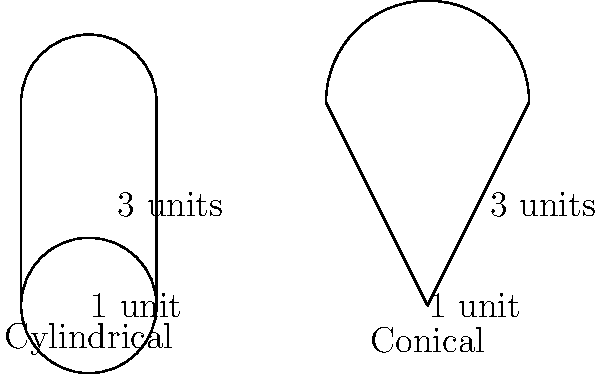You have two protein shaker bottles: a cylindrical one and a conical one. Both are 3 units tall. The cylindrical bottle has a radius of 1 unit, while the conical bottle has a base radius of 1 unit and a top radius of 1.5 units. If you fill the cylindrical bottle completely, what fraction of the conical bottle's volume would be filled with the same amount of protein powder? Let's approach this step-by-step:

1) First, calculate the volume of the cylindrical bottle:
   $$V_{cylinder} = \pi r^2 h = \pi (1)^2 (3) = 3\pi \text{ cubic units}$$

2) Next, calculate the volume of the conical bottle (which is actually a truncated cone):
   $$V_{cone} = \frac{1}{3}\pi h(R^2 + r^2 + Rr)$$
   where $R = 1.5$ (top radius), $r = 1$ (bottom radius), and $h = 3$ (height)
   $$V_{cone} = \frac{1}{3}\pi (3)((1.5)^2 + (1)^2 + 1.5(1)) = \frac{1}{3}\pi (3)(2.25 + 1 + 1.5) = \frac{14.25}{3}\pi \text{ cubic units}$$

3) To find what fraction of the conical bottle would be filled, divide the cylindrical volume by the conical volume:
   $$\text{Fraction} = \frac{V_{cylinder}}{V_{cone}} = \frac{3\pi}{\frac{14.25}{3}\pi} = \frac{3}{\frac{14.25}{3}} = \frac{9}{14.25} = \frac{4}{6.33} \approx 0.6316$$

4) Convert to a fraction:
   $$0.6316 \approx \frac{63}{100} \text{ or } \frac{5}{8}$$

Therefore, the protein powder that fills the cylindrical bottle would fill approximately $\frac{5}{8}$ or 63% of the conical bottle.
Answer: $\frac{5}{8}$ 